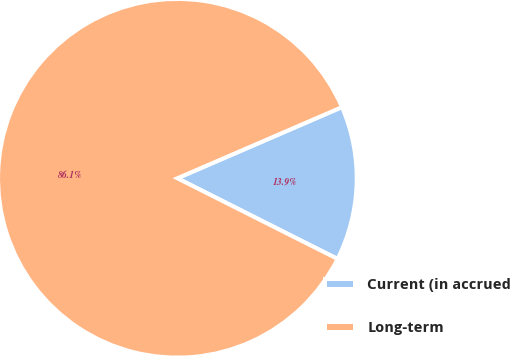Convert chart. <chart><loc_0><loc_0><loc_500><loc_500><pie_chart><fcel>Current (in accrued<fcel>Long-term<nl><fcel>13.92%<fcel>86.08%<nl></chart> 